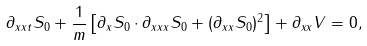Convert formula to latex. <formula><loc_0><loc_0><loc_500><loc_500>\partial _ { x x t } S _ { 0 } + \frac { 1 } { m } \left [ \partial _ { x } S _ { 0 } \cdot \partial _ { x x x } S _ { 0 } + ( \partial _ { x x } S _ { 0 } ) ^ { 2 } \right ] + \partial _ { x x } V = 0 ,</formula> 